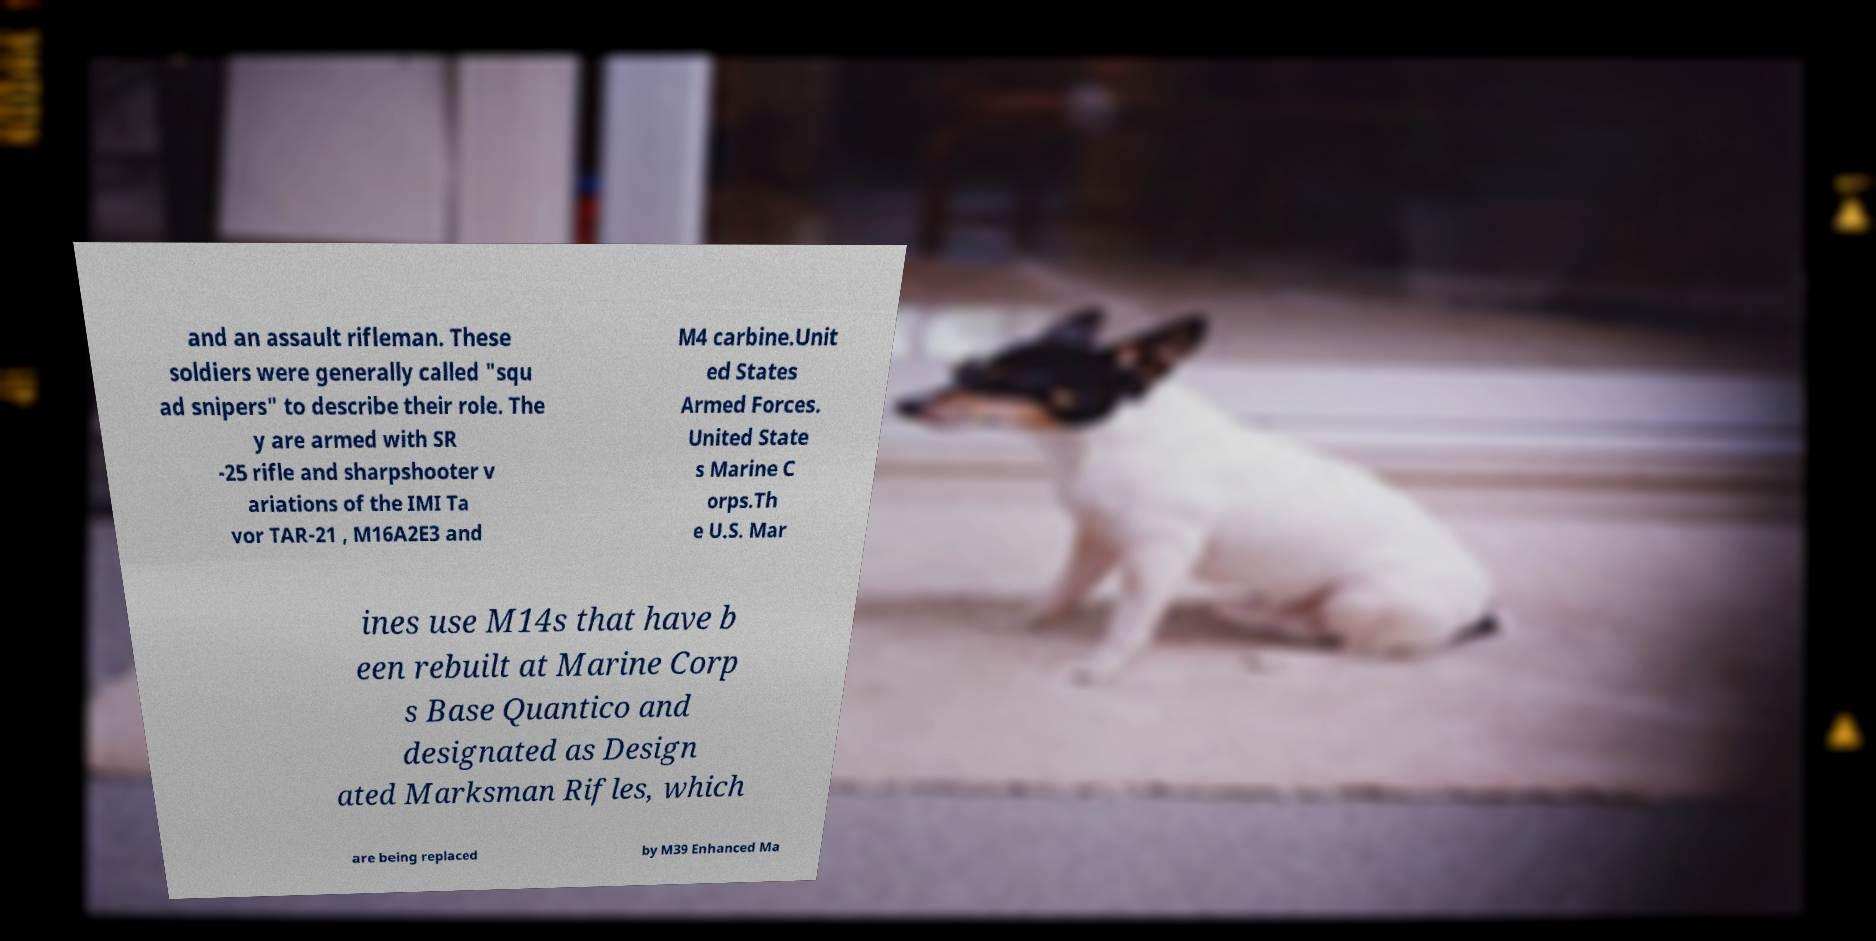Can you read and provide the text displayed in the image?This photo seems to have some interesting text. Can you extract and type it out for me? and an assault rifleman. These soldiers were generally called "squ ad snipers" to describe their role. The y are armed with SR -25 rifle and sharpshooter v ariations of the IMI Ta vor TAR-21 , M16A2E3 and M4 carbine.Unit ed States Armed Forces. United State s Marine C orps.Th e U.S. Mar ines use M14s that have b een rebuilt at Marine Corp s Base Quantico and designated as Design ated Marksman Rifles, which are being replaced by M39 Enhanced Ma 